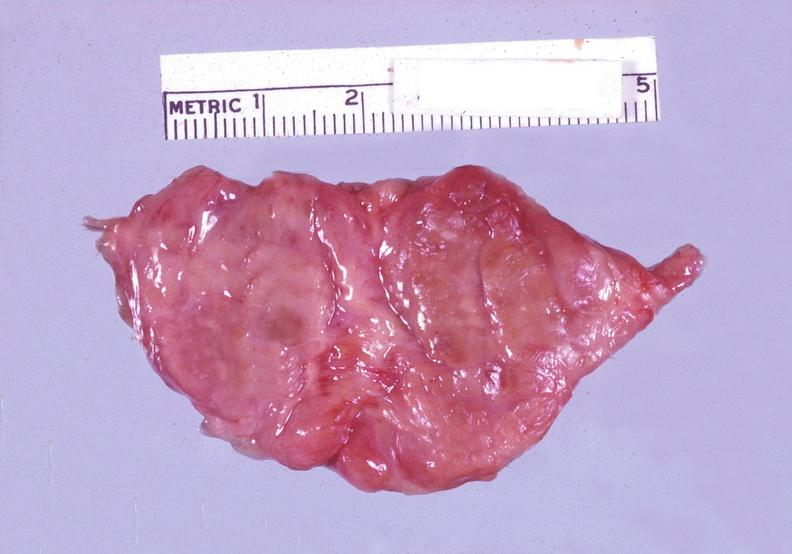s this photo of infant from head to toe present?
Answer the question using a single word or phrase. No 